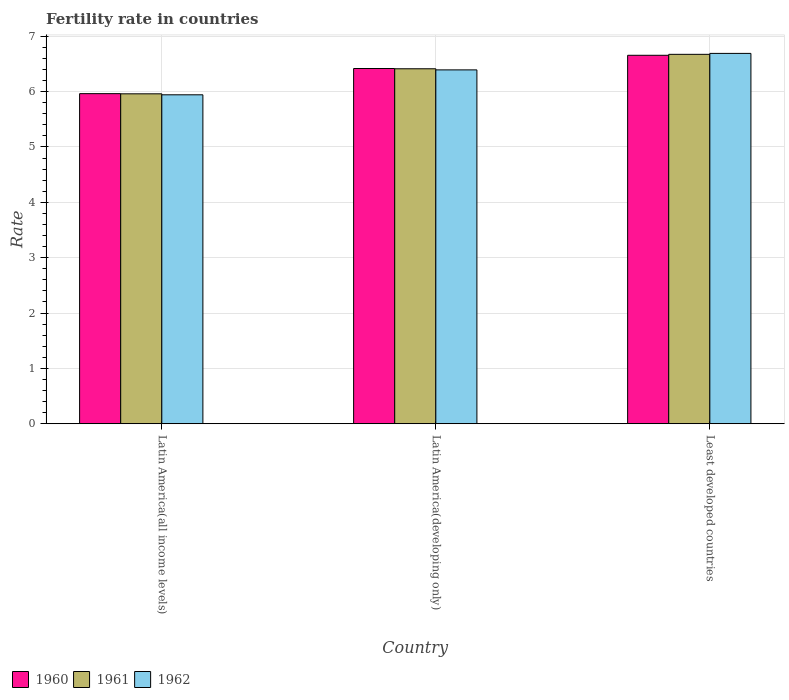How many different coloured bars are there?
Provide a short and direct response. 3. How many groups of bars are there?
Ensure brevity in your answer.  3. Are the number of bars per tick equal to the number of legend labels?
Ensure brevity in your answer.  Yes. Are the number of bars on each tick of the X-axis equal?
Keep it short and to the point. Yes. How many bars are there on the 1st tick from the left?
Keep it short and to the point. 3. What is the label of the 3rd group of bars from the left?
Offer a very short reply. Least developed countries. In how many cases, is the number of bars for a given country not equal to the number of legend labels?
Give a very brief answer. 0. What is the fertility rate in 1960 in Latin America(developing only)?
Offer a terse response. 6.42. Across all countries, what is the maximum fertility rate in 1960?
Provide a succinct answer. 6.66. Across all countries, what is the minimum fertility rate in 1962?
Provide a short and direct response. 5.94. In which country was the fertility rate in 1960 maximum?
Your response must be concise. Least developed countries. In which country was the fertility rate in 1962 minimum?
Your response must be concise. Latin America(all income levels). What is the total fertility rate in 1962 in the graph?
Provide a short and direct response. 19.03. What is the difference between the fertility rate in 1962 in Latin America(developing only) and that in Least developed countries?
Provide a succinct answer. -0.3. What is the difference between the fertility rate in 1962 in Latin America(all income levels) and the fertility rate in 1961 in Latin America(developing only)?
Ensure brevity in your answer.  -0.47. What is the average fertility rate in 1962 per country?
Make the answer very short. 6.34. What is the difference between the fertility rate of/in 1962 and fertility rate of/in 1961 in Least developed countries?
Your answer should be compact. 0.02. What is the ratio of the fertility rate in 1962 in Latin America(all income levels) to that in Least developed countries?
Make the answer very short. 0.89. Is the fertility rate in 1960 in Latin America(all income levels) less than that in Latin America(developing only)?
Keep it short and to the point. Yes. What is the difference between the highest and the second highest fertility rate in 1962?
Make the answer very short. -0.75. What is the difference between the highest and the lowest fertility rate in 1962?
Offer a very short reply. 0.75. In how many countries, is the fertility rate in 1960 greater than the average fertility rate in 1960 taken over all countries?
Keep it short and to the point. 2. What does the 1st bar from the right in Latin America(all income levels) represents?
Ensure brevity in your answer.  1962. Is it the case that in every country, the sum of the fertility rate in 1961 and fertility rate in 1960 is greater than the fertility rate in 1962?
Provide a short and direct response. Yes. How many bars are there?
Keep it short and to the point. 9. How many countries are there in the graph?
Your answer should be very brief. 3. What is the difference between two consecutive major ticks on the Y-axis?
Provide a succinct answer. 1. Does the graph contain any zero values?
Your response must be concise. No. Does the graph contain grids?
Keep it short and to the point. Yes. Where does the legend appear in the graph?
Give a very brief answer. Bottom left. How many legend labels are there?
Provide a succinct answer. 3. What is the title of the graph?
Offer a terse response. Fertility rate in countries. What is the label or title of the Y-axis?
Offer a very short reply. Rate. What is the Rate in 1960 in Latin America(all income levels)?
Your response must be concise. 5.96. What is the Rate in 1961 in Latin America(all income levels)?
Offer a terse response. 5.96. What is the Rate of 1962 in Latin America(all income levels)?
Provide a short and direct response. 5.94. What is the Rate of 1960 in Latin America(developing only)?
Ensure brevity in your answer.  6.42. What is the Rate in 1961 in Latin America(developing only)?
Keep it short and to the point. 6.41. What is the Rate in 1962 in Latin America(developing only)?
Your answer should be compact. 6.39. What is the Rate of 1960 in Least developed countries?
Your response must be concise. 6.66. What is the Rate of 1961 in Least developed countries?
Offer a very short reply. 6.67. What is the Rate of 1962 in Least developed countries?
Make the answer very short. 6.69. Across all countries, what is the maximum Rate in 1960?
Ensure brevity in your answer.  6.66. Across all countries, what is the maximum Rate of 1961?
Give a very brief answer. 6.67. Across all countries, what is the maximum Rate in 1962?
Your answer should be compact. 6.69. Across all countries, what is the minimum Rate of 1960?
Your answer should be very brief. 5.96. Across all countries, what is the minimum Rate in 1961?
Offer a terse response. 5.96. Across all countries, what is the minimum Rate in 1962?
Make the answer very short. 5.94. What is the total Rate of 1960 in the graph?
Your response must be concise. 19.04. What is the total Rate of 1961 in the graph?
Your response must be concise. 19.05. What is the total Rate of 1962 in the graph?
Offer a terse response. 19.03. What is the difference between the Rate of 1960 in Latin America(all income levels) and that in Latin America(developing only)?
Keep it short and to the point. -0.45. What is the difference between the Rate of 1961 in Latin America(all income levels) and that in Latin America(developing only)?
Offer a very short reply. -0.45. What is the difference between the Rate of 1962 in Latin America(all income levels) and that in Latin America(developing only)?
Make the answer very short. -0.45. What is the difference between the Rate of 1960 in Latin America(all income levels) and that in Least developed countries?
Offer a terse response. -0.69. What is the difference between the Rate of 1961 in Latin America(all income levels) and that in Least developed countries?
Ensure brevity in your answer.  -0.71. What is the difference between the Rate in 1962 in Latin America(all income levels) and that in Least developed countries?
Give a very brief answer. -0.75. What is the difference between the Rate in 1960 in Latin America(developing only) and that in Least developed countries?
Your response must be concise. -0.24. What is the difference between the Rate in 1961 in Latin America(developing only) and that in Least developed countries?
Your response must be concise. -0.26. What is the difference between the Rate of 1962 in Latin America(developing only) and that in Least developed countries?
Your answer should be compact. -0.3. What is the difference between the Rate in 1960 in Latin America(all income levels) and the Rate in 1961 in Latin America(developing only)?
Provide a succinct answer. -0.45. What is the difference between the Rate of 1960 in Latin America(all income levels) and the Rate of 1962 in Latin America(developing only)?
Your answer should be very brief. -0.43. What is the difference between the Rate in 1961 in Latin America(all income levels) and the Rate in 1962 in Latin America(developing only)?
Provide a short and direct response. -0.43. What is the difference between the Rate of 1960 in Latin America(all income levels) and the Rate of 1961 in Least developed countries?
Ensure brevity in your answer.  -0.71. What is the difference between the Rate in 1960 in Latin America(all income levels) and the Rate in 1962 in Least developed countries?
Make the answer very short. -0.73. What is the difference between the Rate in 1961 in Latin America(all income levels) and the Rate in 1962 in Least developed countries?
Your answer should be compact. -0.73. What is the difference between the Rate in 1960 in Latin America(developing only) and the Rate in 1961 in Least developed countries?
Make the answer very short. -0.26. What is the difference between the Rate of 1960 in Latin America(developing only) and the Rate of 1962 in Least developed countries?
Offer a very short reply. -0.27. What is the difference between the Rate in 1961 in Latin America(developing only) and the Rate in 1962 in Least developed countries?
Give a very brief answer. -0.28. What is the average Rate of 1960 per country?
Your answer should be very brief. 6.35. What is the average Rate of 1961 per country?
Your answer should be compact. 6.35. What is the average Rate of 1962 per country?
Your response must be concise. 6.34. What is the difference between the Rate of 1960 and Rate of 1961 in Latin America(all income levels)?
Offer a terse response. 0. What is the difference between the Rate in 1960 and Rate in 1962 in Latin America(all income levels)?
Offer a terse response. 0.02. What is the difference between the Rate of 1961 and Rate of 1962 in Latin America(all income levels)?
Your response must be concise. 0.02. What is the difference between the Rate of 1960 and Rate of 1961 in Latin America(developing only)?
Your answer should be compact. 0.01. What is the difference between the Rate of 1960 and Rate of 1962 in Latin America(developing only)?
Your response must be concise. 0.03. What is the difference between the Rate in 1960 and Rate in 1961 in Least developed countries?
Provide a succinct answer. -0.02. What is the difference between the Rate in 1960 and Rate in 1962 in Least developed countries?
Your answer should be very brief. -0.03. What is the difference between the Rate in 1961 and Rate in 1962 in Least developed countries?
Offer a terse response. -0.02. What is the ratio of the Rate in 1960 in Latin America(all income levels) to that in Latin America(developing only)?
Offer a terse response. 0.93. What is the ratio of the Rate of 1961 in Latin America(all income levels) to that in Latin America(developing only)?
Your answer should be very brief. 0.93. What is the ratio of the Rate in 1962 in Latin America(all income levels) to that in Latin America(developing only)?
Keep it short and to the point. 0.93. What is the ratio of the Rate of 1960 in Latin America(all income levels) to that in Least developed countries?
Your answer should be compact. 0.9. What is the ratio of the Rate of 1961 in Latin America(all income levels) to that in Least developed countries?
Provide a short and direct response. 0.89. What is the ratio of the Rate of 1962 in Latin America(all income levels) to that in Least developed countries?
Give a very brief answer. 0.89. What is the ratio of the Rate of 1960 in Latin America(developing only) to that in Least developed countries?
Make the answer very short. 0.96. What is the ratio of the Rate in 1961 in Latin America(developing only) to that in Least developed countries?
Your response must be concise. 0.96. What is the ratio of the Rate in 1962 in Latin America(developing only) to that in Least developed countries?
Give a very brief answer. 0.96. What is the difference between the highest and the second highest Rate in 1960?
Ensure brevity in your answer.  0.24. What is the difference between the highest and the second highest Rate of 1961?
Offer a terse response. 0.26. What is the difference between the highest and the second highest Rate in 1962?
Provide a succinct answer. 0.3. What is the difference between the highest and the lowest Rate in 1960?
Your answer should be compact. 0.69. What is the difference between the highest and the lowest Rate of 1961?
Your answer should be compact. 0.71. What is the difference between the highest and the lowest Rate of 1962?
Ensure brevity in your answer.  0.75. 